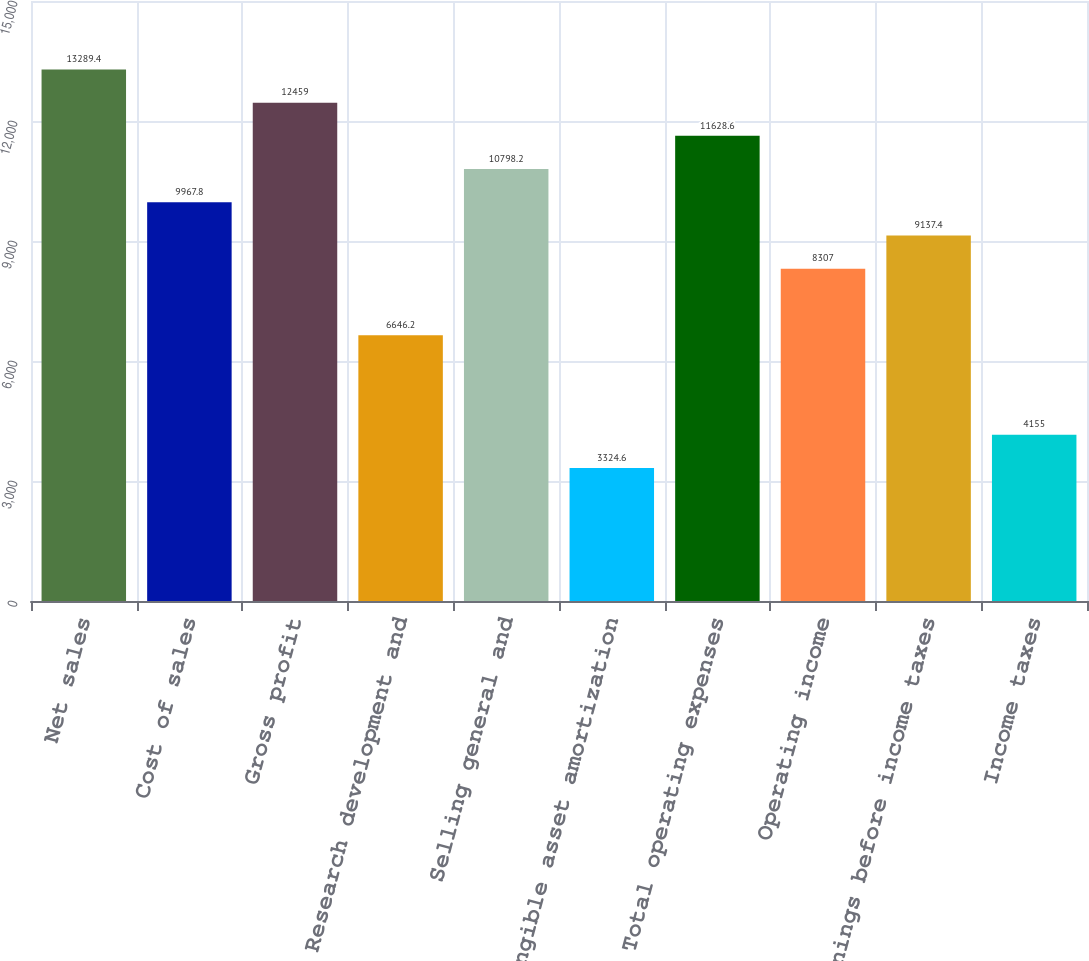Convert chart. <chart><loc_0><loc_0><loc_500><loc_500><bar_chart><fcel>Net sales<fcel>Cost of sales<fcel>Gross profit<fcel>Research development and<fcel>Selling general and<fcel>Intangible asset amortization<fcel>Total operating expenses<fcel>Operating income<fcel>Earnings before income taxes<fcel>Income taxes<nl><fcel>13289.4<fcel>9967.8<fcel>12459<fcel>6646.2<fcel>10798.2<fcel>3324.6<fcel>11628.6<fcel>8307<fcel>9137.4<fcel>4155<nl></chart> 